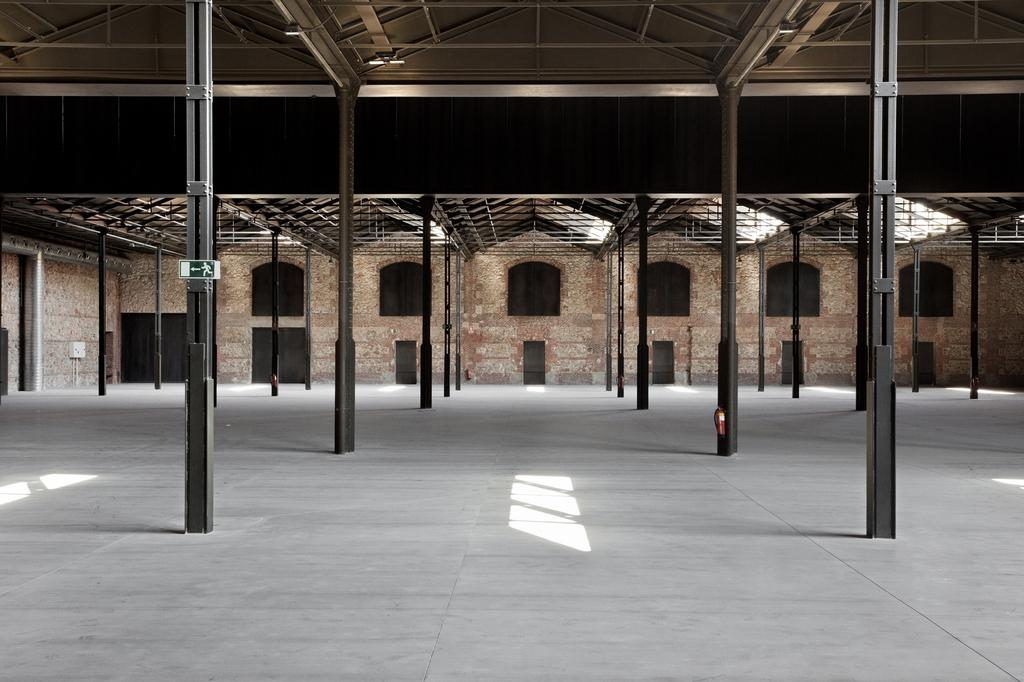What type of structure is visible in the image? There is a building in the image. What is located in front of the building? There are sheds in front of the building. What other objects can be seen in the image? There are poles and a sign board on a pole in the image. Are there any openings in the building? Yes, there are windows in the image. What color is the dust on the button in the image? There is no dust or button present in the image. What is the wish of the person standing next to the building in the image? There is no person standing next to the building in the image. 